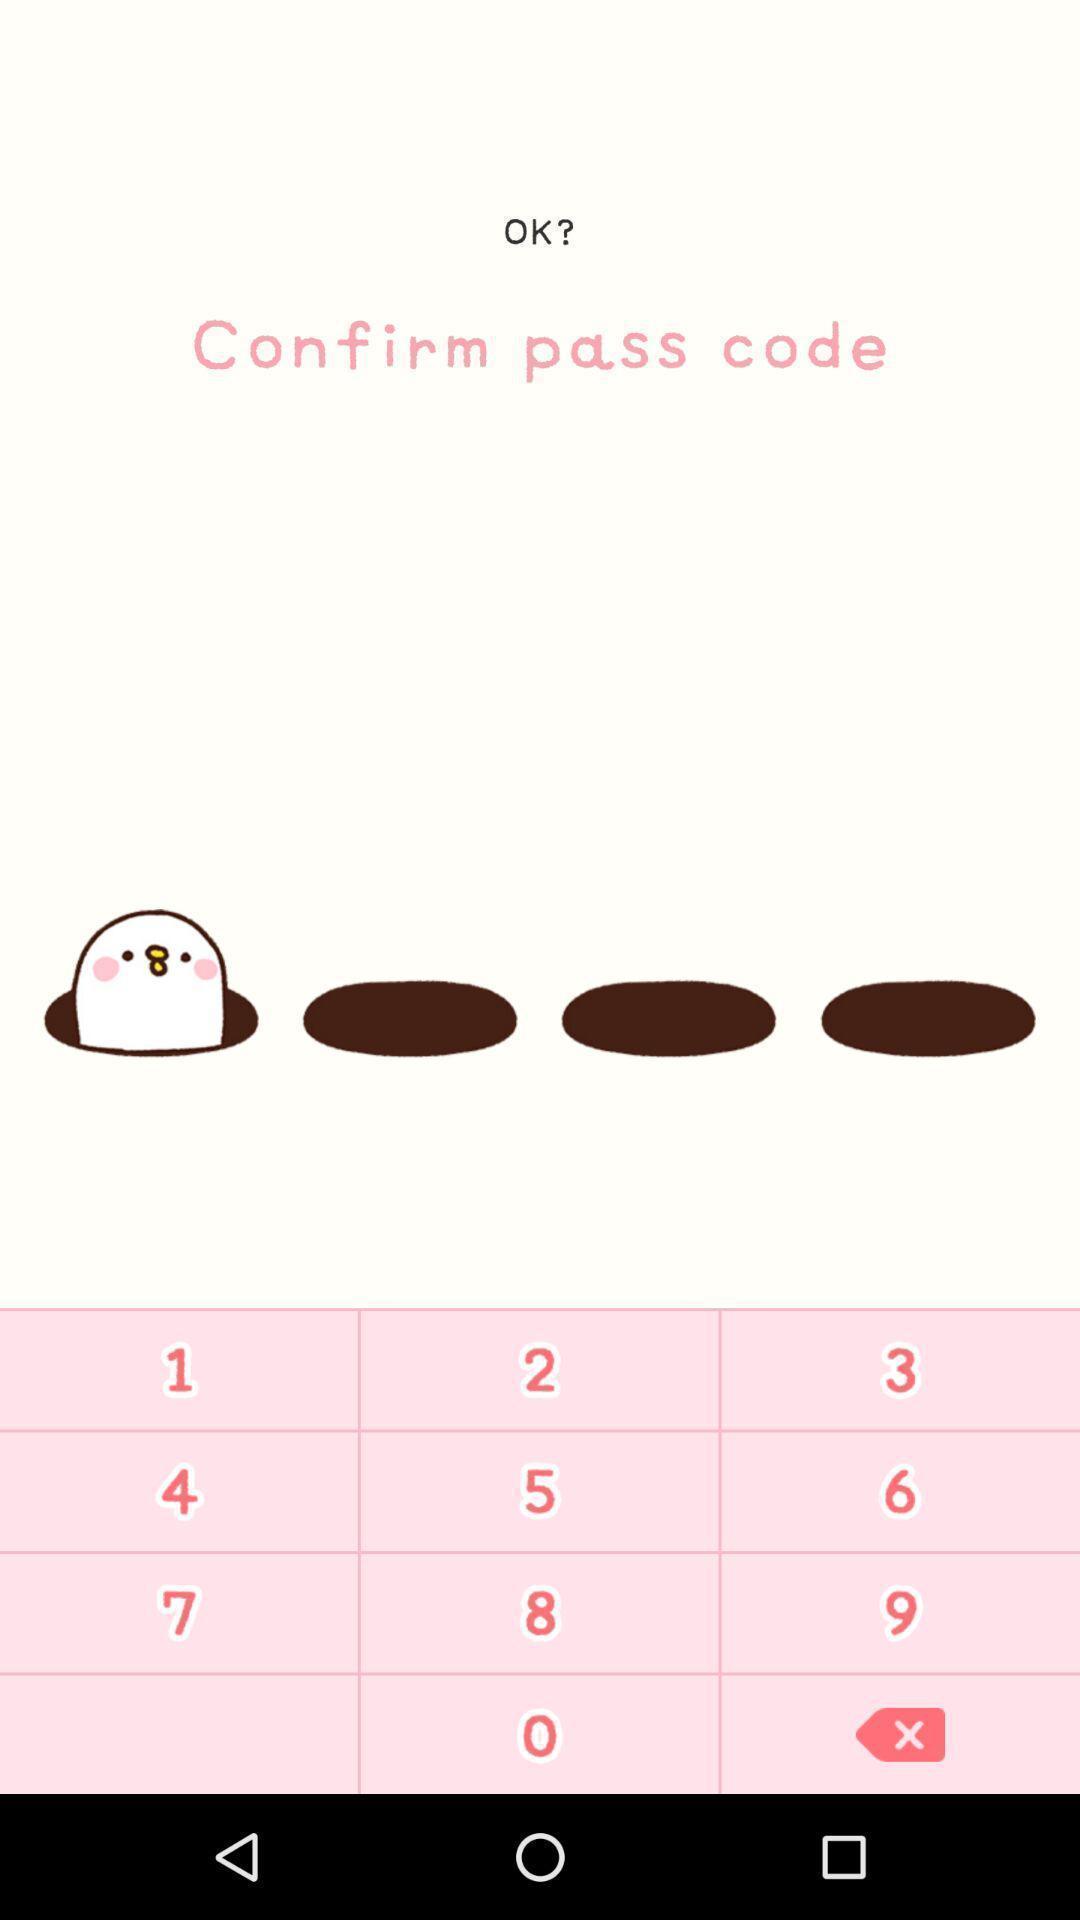Please provide a description for this image. Weight-management app asking for pass code authentication. 